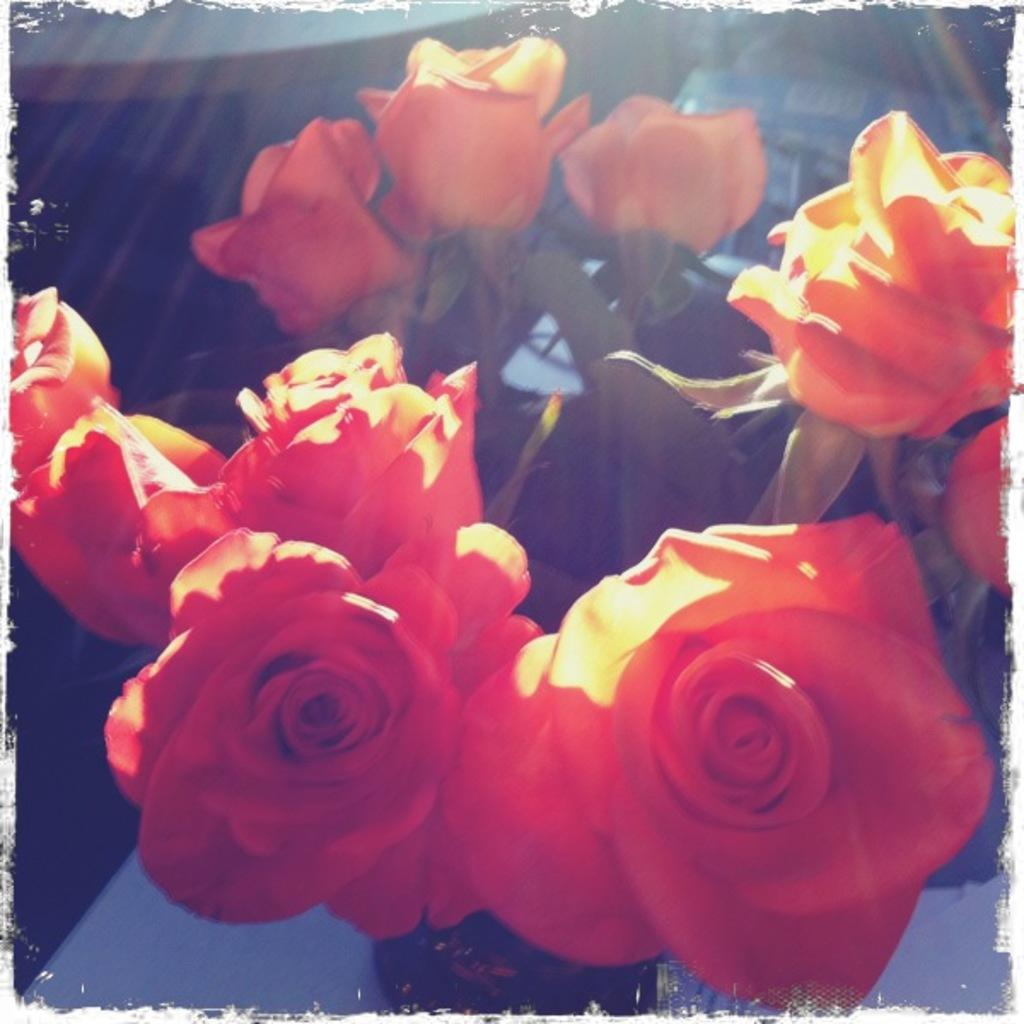What object is present in the image that is typically used for holding flowers? There is a flower vase in the image. Where is the flower vase located? The flower vase is on a table. Can you describe the contents of the flower vase? There is at least one flower in the vase. What type of thread can be seen connecting the flowers in the image? There is no thread connecting the flowers in the image; the flowers are simply placed in the vase. 